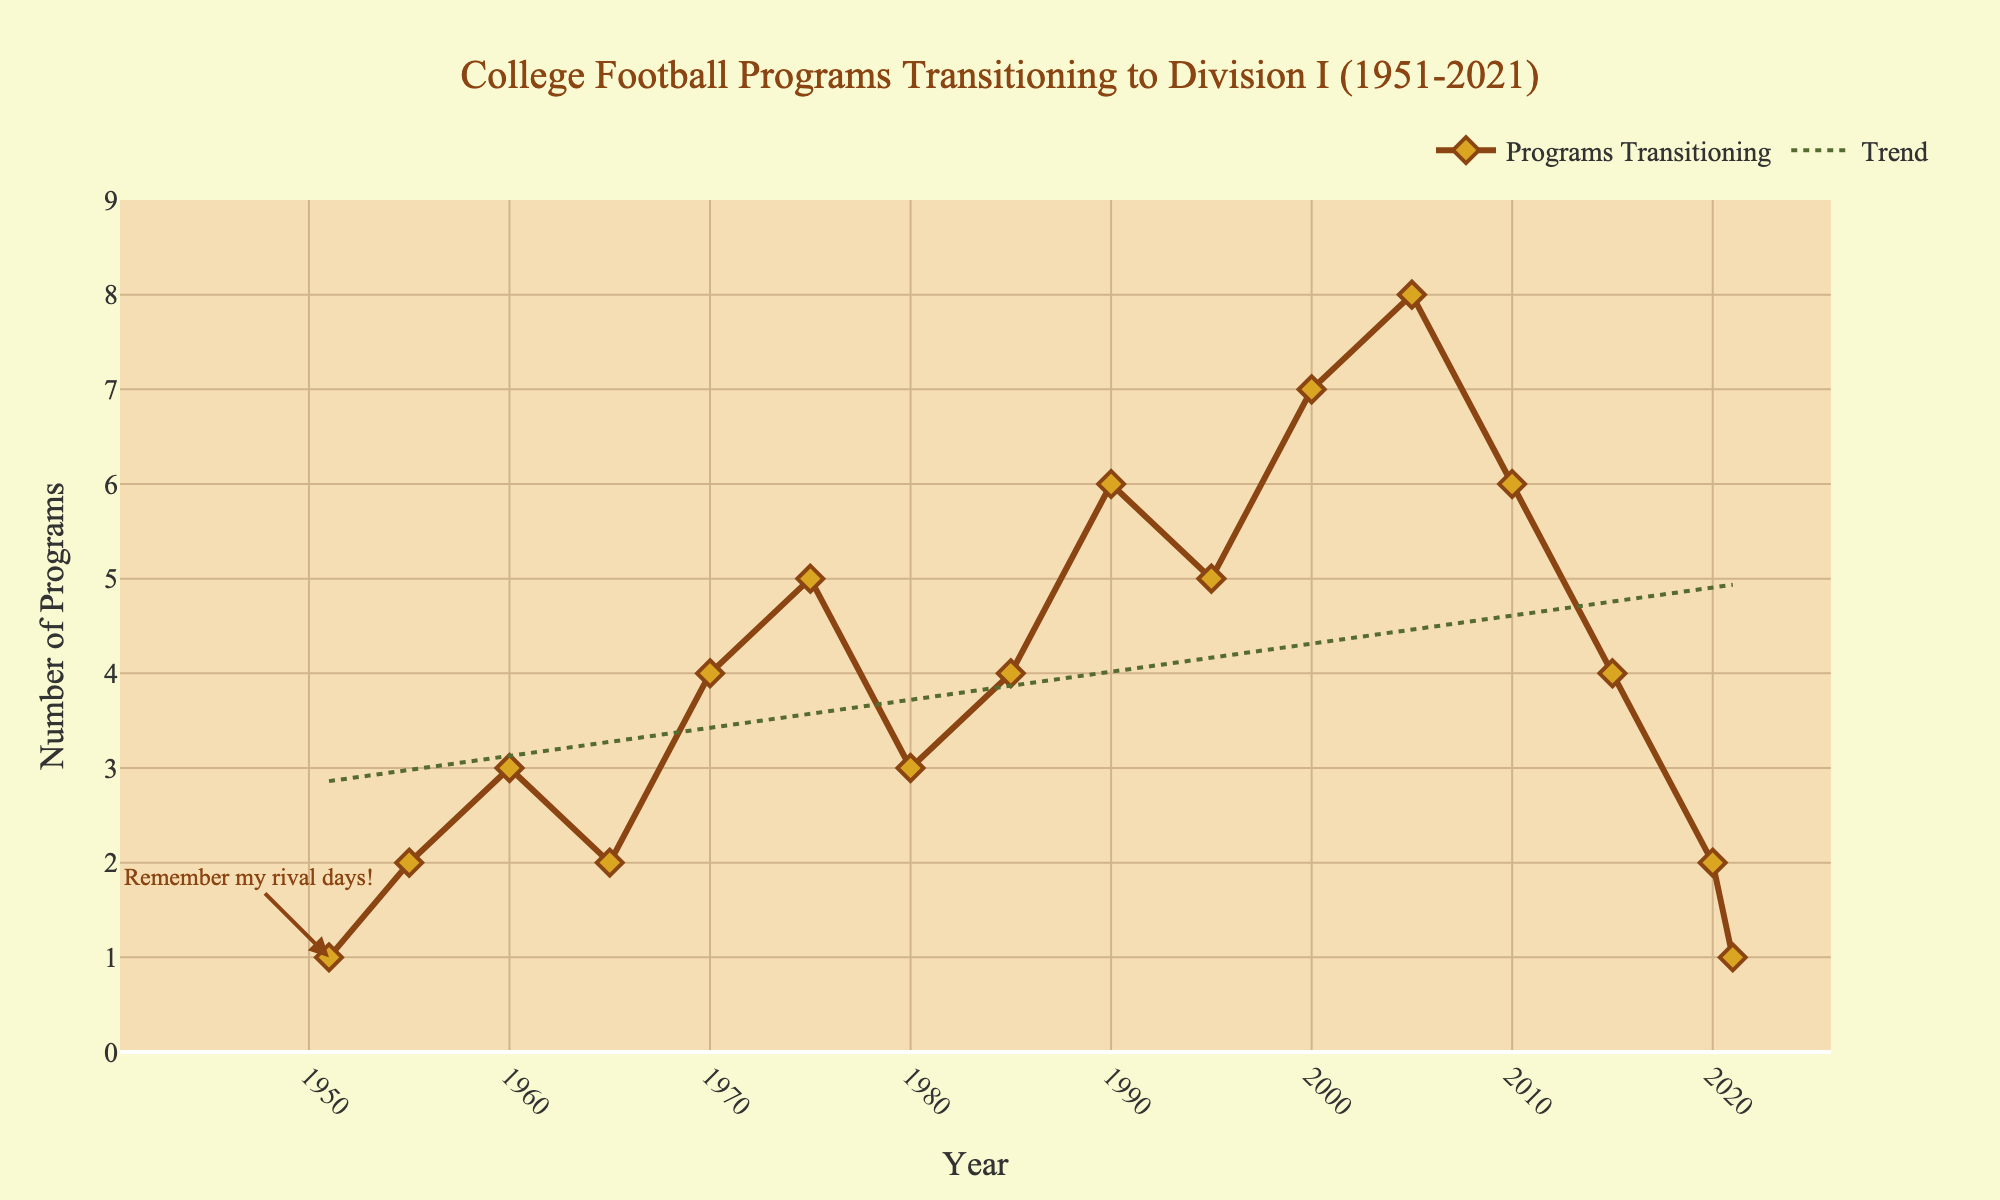What year had the highest number of programs transitioning to Division I? Look at the y-axis values and identify the tallest peak or the highest point on the line. The highest number of programs transitioned in the year 2005.
Answer: 2005 What is the general trend of the number of programs transitioning to Division I over time? Observe the trend line added to the plot. It's a dotted green line which shows an overall increasing trend over time.
Answer: Increasing Between which two consecutive years is the biggest increase in the number of programs transitioning to Division I? Compare the differences in values between each consecutive pair of years. The biggest increase is between 1995 (5) and 2000 (7).
Answer: 1995 and 2000 What is the sum of the number of programs transitioning to Division I in the years 1975, 1980, and 1985? Add the values from the plot for the years 1975, 1980, and 1985: 5 (1975) + 3 (1980) + 4 (1985) = 12.
Answer: 12 During which decade did the number of programs transitioning to Division I generally peak and then decline? Analyze the line and intervals. The count peaks in the 2000s and then declines in the 2010s.
Answer: 2000s Compare the number of programs transitioning in 1960 with those in 1970. Which year had more, and by how much? Look at the values for both years: 3 (1960) and 4 (1970). The year 1970 had more programs by 1.
Answer: 1970, by 1 How many programs transitioned to Division I from 1990 to 2021? Sum the values from the year 1990 to 2021: 6 (1990) + 5 (1995) + 7 (2000) + 8 (2005) + 6 (2010) + 4 (2015) + 2 (2020) + 1 (2021) = 39.
Answer: 39 Which year had an annotation on the graph, and what did it say? Look for any text annotations on the plot. The year 1951 had an annotation that says, "Remember my rival days!".
Answer: 1951, "Remember my rival days" 